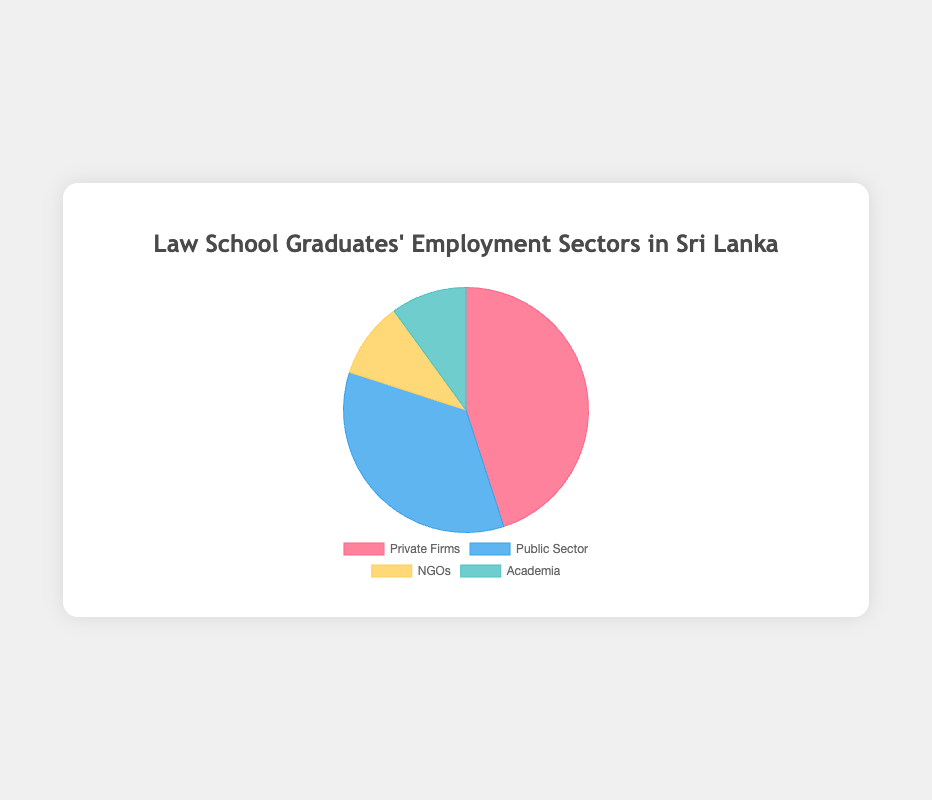What percentage of law school graduates are employed in the Private Firms sector? The pie chart shows that 45% of law school graduates are employed in Private Firms.
Answer: 45% Comparing Private Firms and Public Sector, which sector employs a higher percentage of graduates? The pie chart indicates that Private Firms employ 45% of graduates, while the Public Sector employs 35%. Thus, Private Firms employ a higher percentage of graduates.
Answer: Private Firms What's the combined percentage of graduates employed in NGOs and Academia? From the chart, NGOs have 10% and Academia has 10%, so combined they employ \(10% + 10% = 20%\) of the graduates.
Answer: 20% Which sector has the lowest employment percentage, and what is that percentage? Both NGOs and Academia have the same lowest percentage of 10%, as indicated by their equal-sized slices on the pie chart.
Answer: 10% What's the difference in percentage between graduates in the Private Firms and Public Sector? The percentage of graduates in Private Firms is 45% and in Public Sector is 35%. The difference is calculated as \(45% - 35% = 10%\).
Answer: 10% Which sectors have an equal percentage of graduates? NGOs and Academia both have 10% of graduates, as shown by their equal slices in the pie chart.
Answer: NGOs, Academia Combining all other sectors except Private Firms, what percentage of graduates are employed? Adding the percentages of Public Sector (35%), NGOs (10%), and Academia (10%) gives us \(35% + 10% + 10% = 55%\).
Answer: 55% What color represents the Public Sector in the pie chart? The legend attached to the pie chart indicates that the Public Sector is represented by the color blue.
Answer: Blue Is the percentage of graduates in NGOs higher, lower, or equal to that in Academia? Both sectors have the same employment percentage of 10%, as represented by equal-sized slices in the pie chart.
Answer: Equal How does the employment percentage of the Public Sector compare to the total percentage of NGOs and Academia combined? The Public Sector has an employment percentage of 35%, whereas the combined percentage for NGOs and Academia is \(10% + 10% = 20%\). Thus, the Public Sector employs a higher percentage.
Answer: Higher 